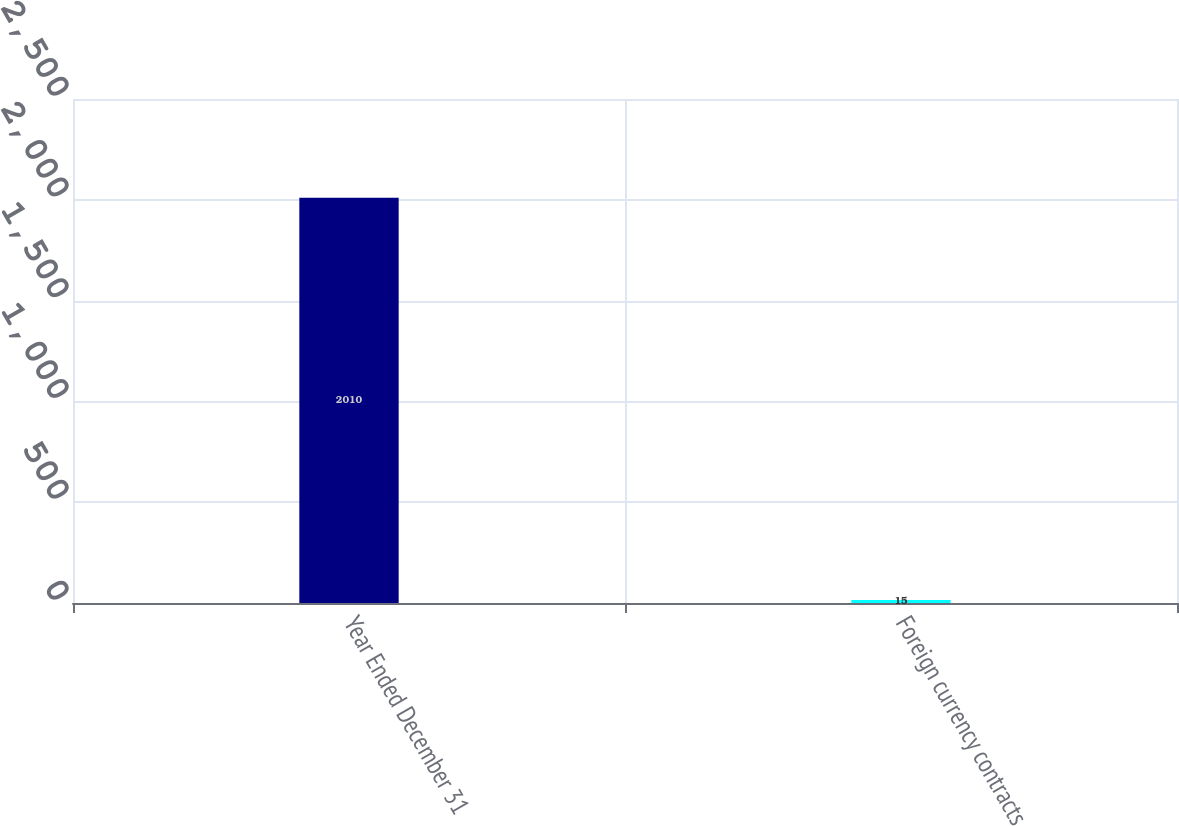Convert chart to OTSL. <chart><loc_0><loc_0><loc_500><loc_500><bar_chart><fcel>Year Ended December 31<fcel>Foreign currency contracts<nl><fcel>2010<fcel>15<nl></chart> 